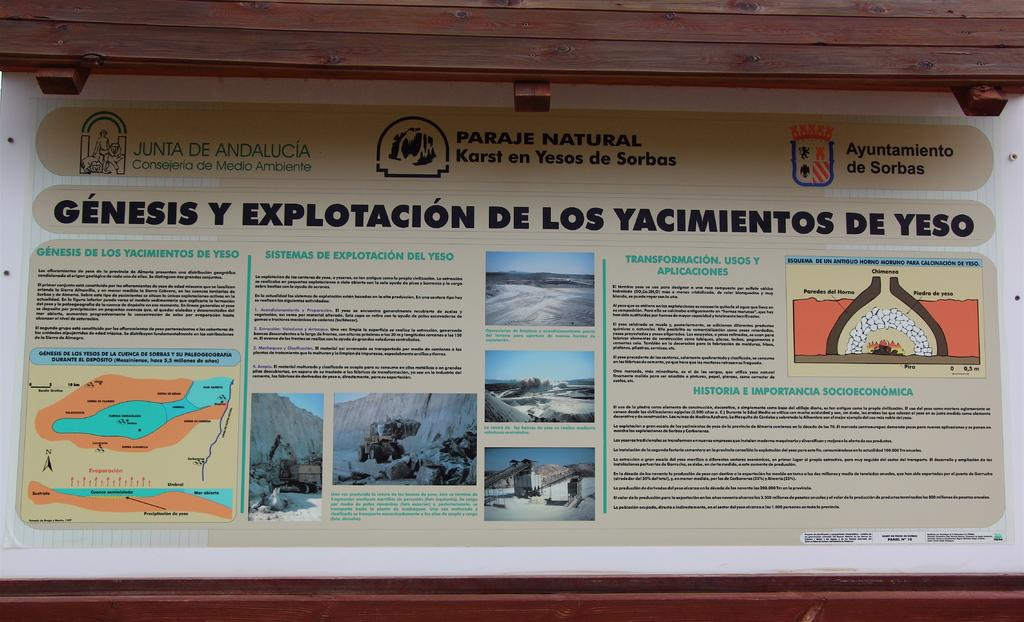<image>
Provide a brief description of the given image. a infographic that is titled genesis y explotacion de los yacimientos de yeso. 